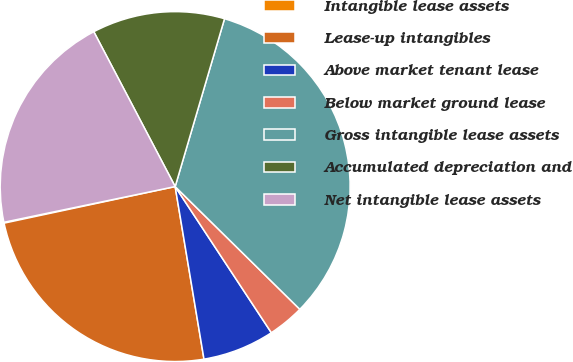<chart> <loc_0><loc_0><loc_500><loc_500><pie_chart><fcel>Intangible lease assets<fcel>Lease-up intangibles<fcel>Above market tenant lease<fcel>Below market ground lease<fcel>Gross intangible lease assets<fcel>Accumulated depreciation and<fcel>Net intangible lease assets<nl><fcel>0.08%<fcel>24.28%<fcel>6.63%<fcel>3.36%<fcel>32.82%<fcel>12.25%<fcel>20.57%<nl></chart> 